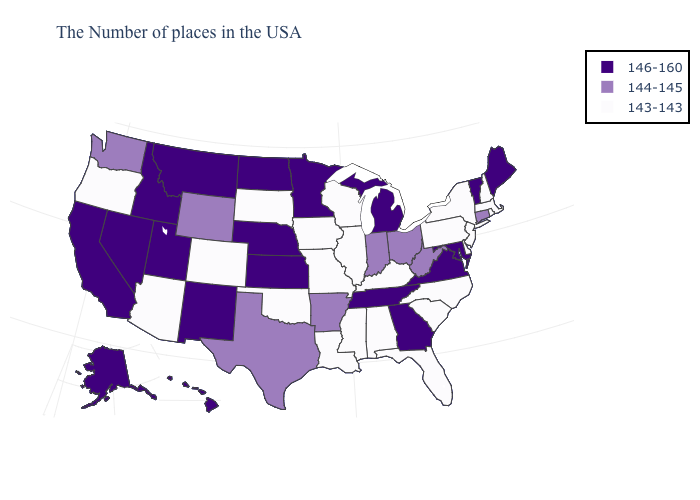Does Ohio have a higher value than Louisiana?
Give a very brief answer. Yes. Name the states that have a value in the range 146-160?
Be succinct. Maine, Vermont, Maryland, Virginia, Georgia, Michigan, Tennessee, Minnesota, Kansas, Nebraska, North Dakota, New Mexico, Utah, Montana, Idaho, Nevada, California, Alaska, Hawaii. What is the value of Hawaii?
Short answer required. 146-160. What is the value of Kansas?
Give a very brief answer. 146-160. What is the value of Washington?
Keep it brief. 144-145. What is the value of Arkansas?
Quick response, please. 144-145. What is the value of New Mexico?
Keep it brief. 146-160. Name the states that have a value in the range 146-160?
Give a very brief answer. Maine, Vermont, Maryland, Virginia, Georgia, Michigan, Tennessee, Minnesota, Kansas, Nebraska, North Dakota, New Mexico, Utah, Montana, Idaho, Nevada, California, Alaska, Hawaii. Which states have the lowest value in the USA?
Quick response, please. Massachusetts, Rhode Island, New Hampshire, New York, New Jersey, Delaware, Pennsylvania, North Carolina, South Carolina, Florida, Kentucky, Alabama, Wisconsin, Illinois, Mississippi, Louisiana, Missouri, Iowa, Oklahoma, South Dakota, Colorado, Arizona, Oregon. Name the states that have a value in the range 146-160?
Answer briefly. Maine, Vermont, Maryland, Virginia, Georgia, Michigan, Tennessee, Minnesota, Kansas, Nebraska, North Dakota, New Mexico, Utah, Montana, Idaho, Nevada, California, Alaska, Hawaii. Which states have the highest value in the USA?
Short answer required. Maine, Vermont, Maryland, Virginia, Georgia, Michigan, Tennessee, Minnesota, Kansas, Nebraska, North Dakota, New Mexico, Utah, Montana, Idaho, Nevada, California, Alaska, Hawaii. Among the states that border Ohio , does Pennsylvania have the lowest value?
Short answer required. Yes. What is the value of Idaho?
Keep it brief. 146-160. 